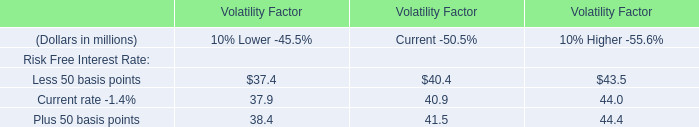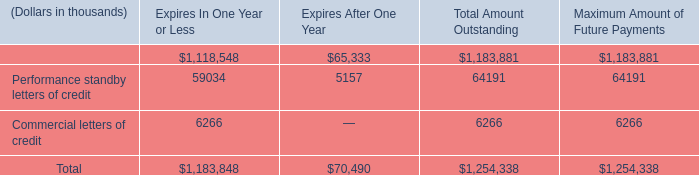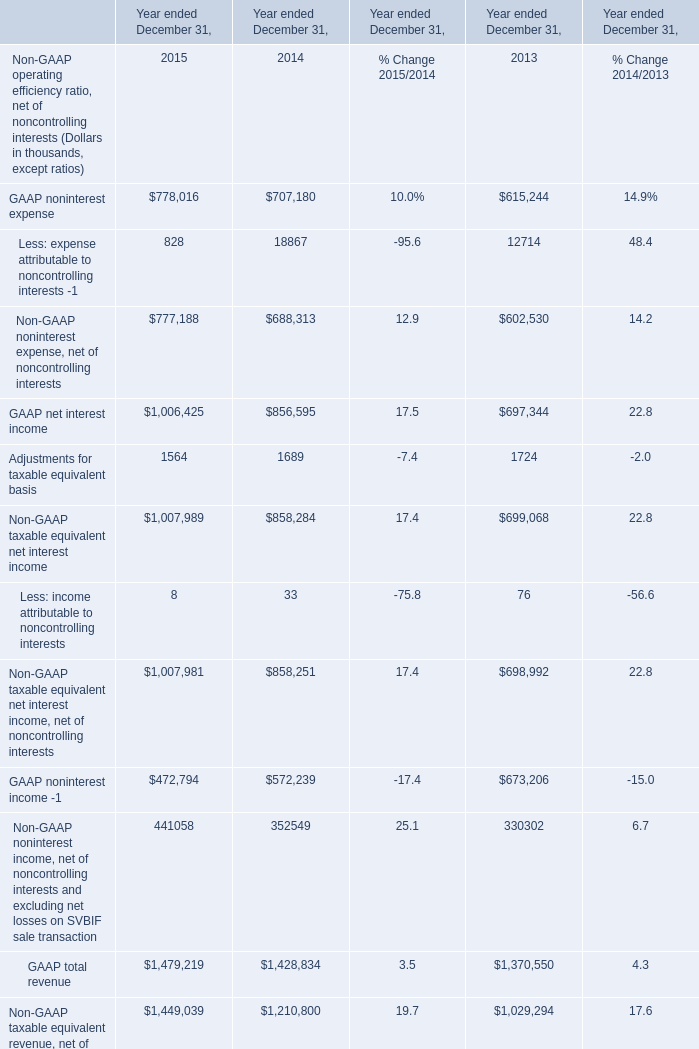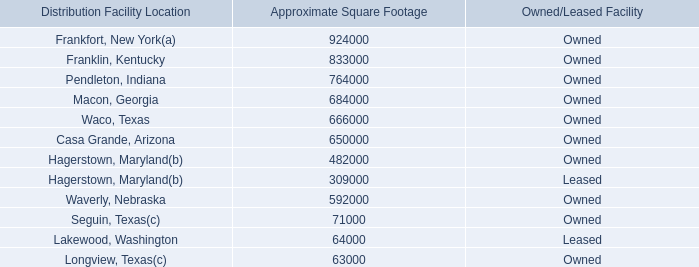What is the sum of GAAP net interest income in 2015 and Commercial letters of credit for Expires In One Year or Less? (in thousand) 
Computations: (1006425 + 6266)
Answer: 1012691.0. 